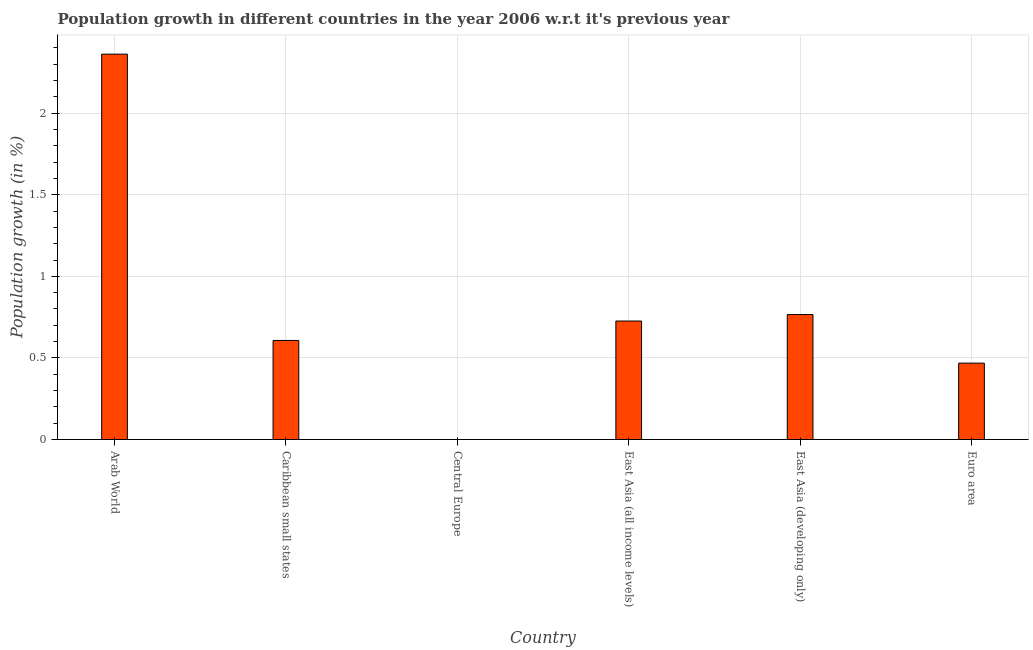Does the graph contain any zero values?
Make the answer very short. Yes. Does the graph contain grids?
Offer a terse response. Yes. What is the title of the graph?
Make the answer very short. Population growth in different countries in the year 2006 w.r.t it's previous year. What is the label or title of the X-axis?
Give a very brief answer. Country. What is the label or title of the Y-axis?
Offer a very short reply. Population growth (in %). What is the population growth in East Asia (all income levels)?
Give a very brief answer. 0.73. Across all countries, what is the maximum population growth?
Keep it short and to the point. 2.36. Across all countries, what is the minimum population growth?
Your answer should be compact. 0. In which country was the population growth maximum?
Provide a short and direct response. Arab World. What is the sum of the population growth?
Your response must be concise. 4.93. What is the difference between the population growth in Caribbean small states and Euro area?
Your response must be concise. 0.14. What is the average population growth per country?
Provide a short and direct response. 0.82. What is the median population growth?
Your answer should be very brief. 0.67. What is the ratio of the population growth in Arab World to that in Caribbean small states?
Your answer should be very brief. 3.89. Is the population growth in East Asia (all income levels) less than that in East Asia (developing only)?
Provide a succinct answer. Yes. What is the difference between the highest and the second highest population growth?
Provide a short and direct response. 1.6. What is the difference between the highest and the lowest population growth?
Provide a short and direct response. 2.36. In how many countries, is the population growth greater than the average population growth taken over all countries?
Provide a short and direct response. 1. How many countries are there in the graph?
Provide a succinct answer. 6. Are the values on the major ticks of Y-axis written in scientific E-notation?
Provide a succinct answer. No. What is the Population growth (in %) in Arab World?
Keep it short and to the point. 2.36. What is the Population growth (in %) of Caribbean small states?
Ensure brevity in your answer.  0.61. What is the Population growth (in %) in Central Europe?
Ensure brevity in your answer.  0. What is the Population growth (in %) of East Asia (all income levels)?
Your answer should be very brief. 0.73. What is the Population growth (in %) of East Asia (developing only)?
Your answer should be compact. 0.77. What is the Population growth (in %) in Euro area?
Offer a very short reply. 0.47. What is the difference between the Population growth (in %) in Arab World and Caribbean small states?
Provide a succinct answer. 1.75. What is the difference between the Population growth (in %) in Arab World and East Asia (all income levels)?
Make the answer very short. 1.64. What is the difference between the Population growth (in %) in Arab World and East Asia (developing only)?
Keep it short and to the point. 1.6. What is the difference between the Population growth (in %) in Arab World and Euro area?
Offer a very short reply. 1.89. What is the difference between the Population growth (in %) in Caribbean small states and East Asia (all income levels)?
Your answer should be very brief. -0.12. What is the difference between the Population growth (in %) in Caribbean small states and East Asia (developing only)?
Provide a succinct answer. -0.16. What is the difference between the Population growth (in %) in Caribbean small states and Euro area?
Your response must be concise. 0.14. What is the difference between the Population growth (in %) in East Asia (all income levels) and East Asia (developing only)?
Make the answer very short. -0.04. What is the difference between the Population growth (in %) in East Asia (all income levels) and Euro area?
Give a very brief answer. 0.26. What is the difference between the Population growth (in %) in East Asia (developing only) and Euro area?
Your answer should be very brief. 0.3. What is the ratio of the Population growth (in %) in Arab World to that in Caribbean small states?
Offer a terse response. 3.89. What is the ratio of the Population growth (in %) in Arab World to that in East Asia (all income levels)?
Provide a short and direct response. 3.25. What is the ratio of the Population growth (in %) in Arab World to that in East Asia (developing only)?
Give a very brief answer. 3.08. What is the ratio of the Population growth (in %) in Arab World to that in Euro area?
Give a very brief answer. 5.04. What is the ratio of the Population growth (in %) in Caribbean small states to that in East Asia (all income levels)?
Give a very brief answer. 0.84. What is the ratio of the Population growth (in %) in Caribbean small states to that in East Asia (developing only)?
Offer a terse response. 0.79. What is the ratio of the Population growth (in %) in Caribbean small states to that in Euro area?
Your response must be concise. 1.3. What is the ratio of the Population growth (in %) in East Asia (all income levels) to that in East Asia (developing only)?
Give a very brief answer. 0.95. What is the ratio of the Population growth (in %) in East Asia (all income levels) to that in Euro area?
Ensure brevity in your answer.  1.55. What is the ratio of the Population growth (in %) in East Asia (developing only) to that in Euro area?
Offer a very short reply. 1.64. 